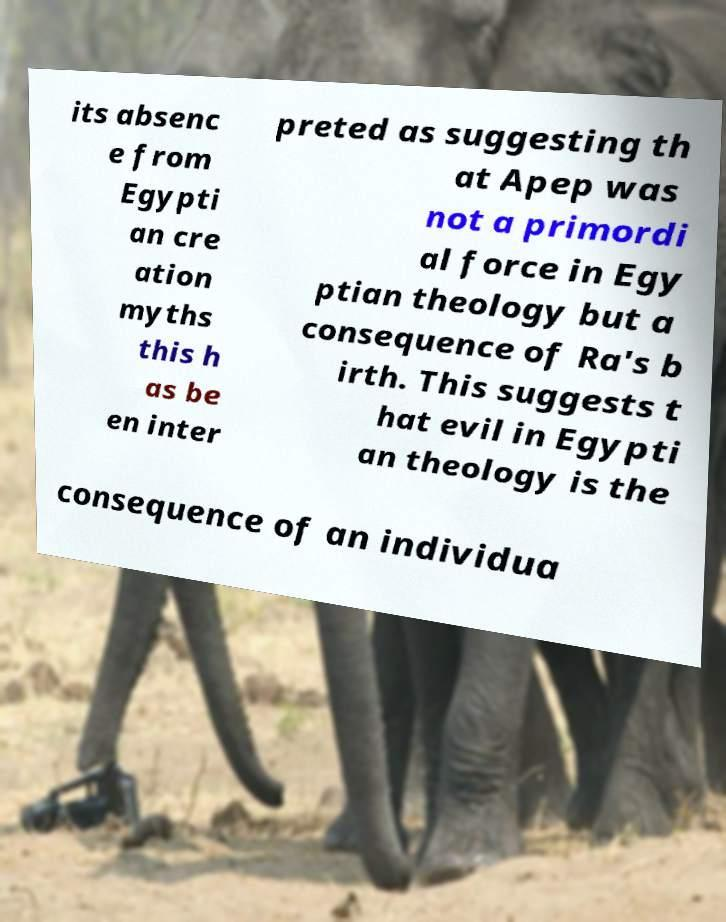Can you read and provide the text displayed in the image?This photo seems to have some interesting text. Can you extract and type it out for me? its absenc e from Egypti an cre ation myths this h as be en inter preted as suggesting th at Apep was not a primordi al force in Egy ptian theology but a consequence of Ra's b irth. This suggests t hat evil in Egypti an theology is the consequence of an individua 